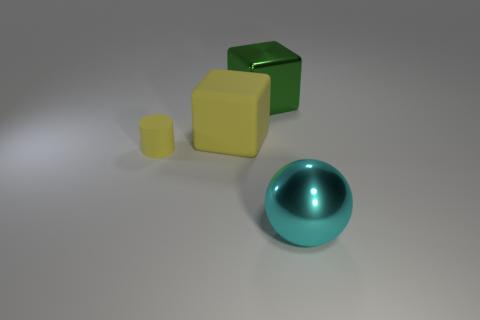Subtract all yellow balls. Subtract all cyan cubes. How many balls are left? 1 Add 3 large cyan metallic things. How many objects exist? 7 Subtract all spheres. How many objects are left? 3 Add 4 cylinders. How many cylinders are left? 5 Add 2 tiny red metallic things. How many tiny red metallic things exist? 2 Subtract 0 yellow balls. How many objects are left? 4 Subtract all tiny cyan metal spheres. Subtract all large green blocks. How many objects are left? 3 